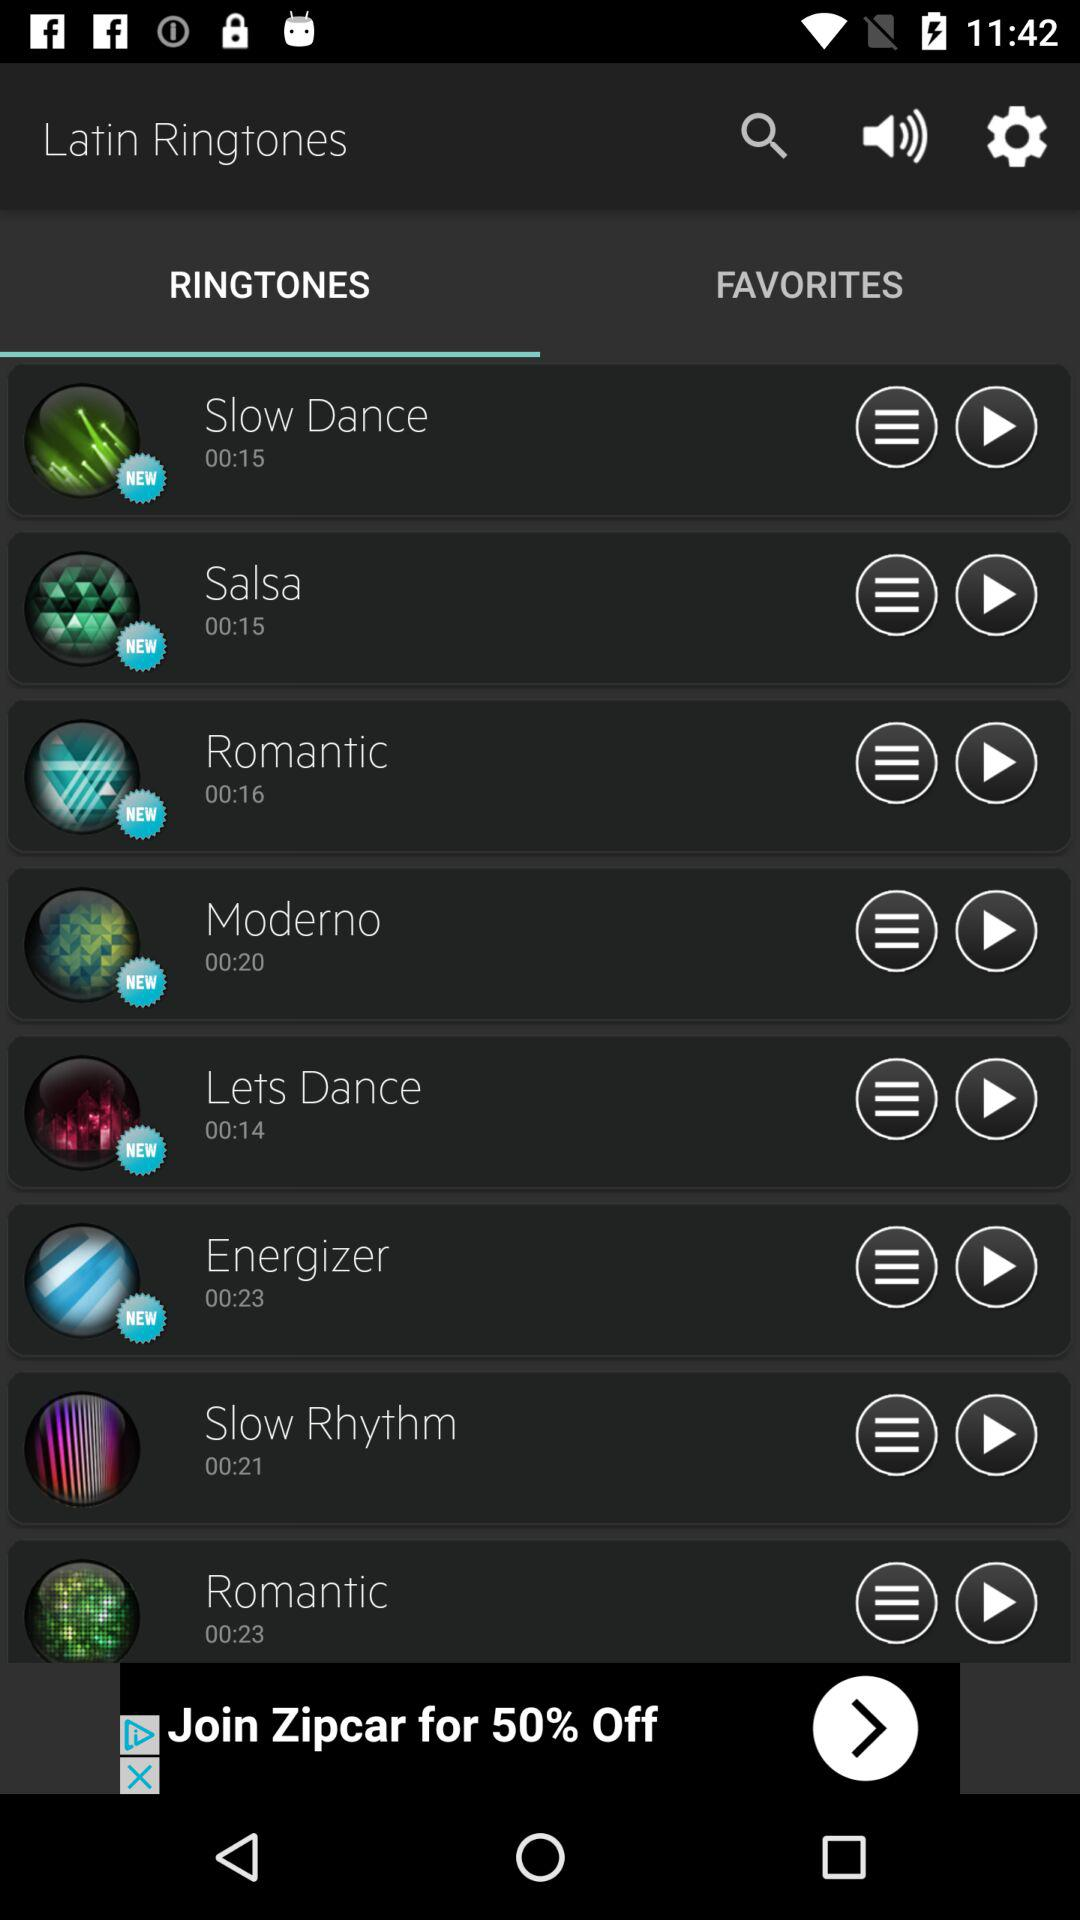What is the duration of the "Salsa"? The duration is 15 seconds. 